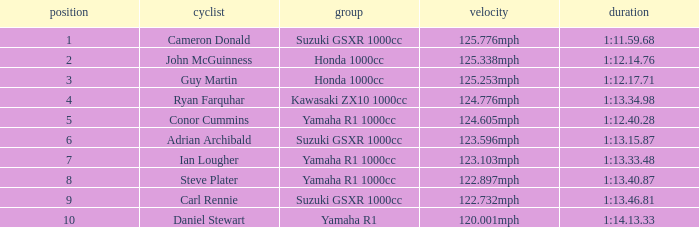What time did team kawasaki zx10 1000cc have? 1:13.34.98. 